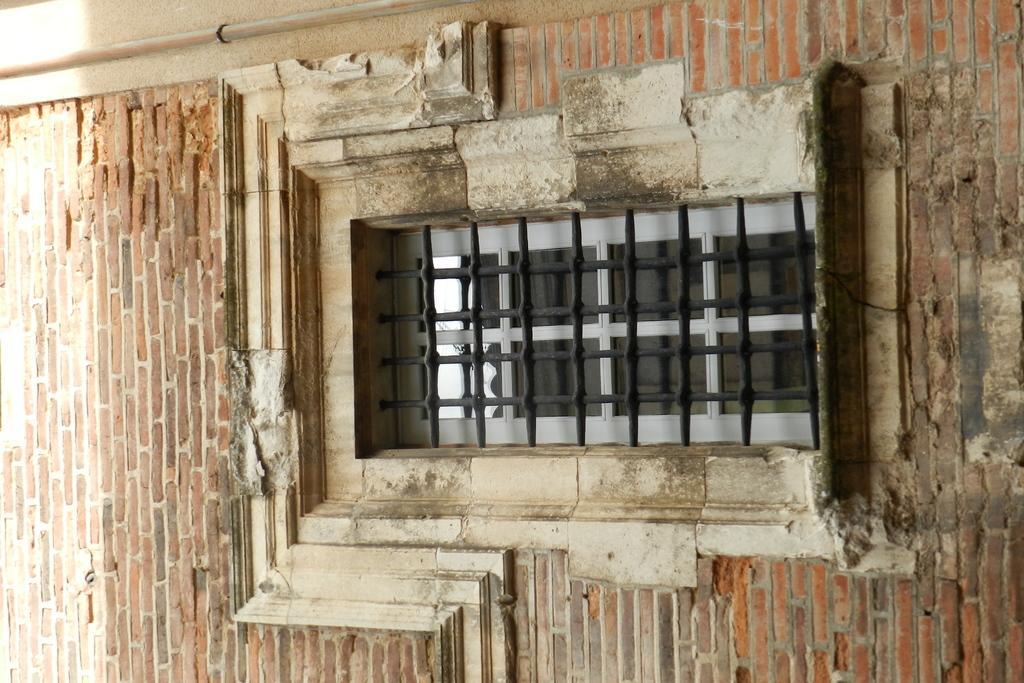How would you summarize this image in a sentence or two? This picture might be taken from outside of the building. In this image, in the middle, we can also see a grill window. In the background, we can see a brick wall and pipes. 